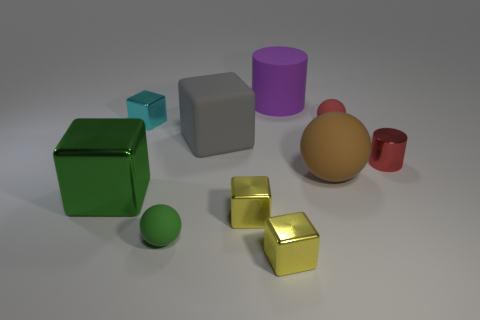Subtract all small red matte spheres. How many spheres are left? 2 Subtract all brown spheres. How many spheres are left? 2 Subtract all cylinders. How many objects are left? 8 Subtract 3 cubes. How many cubes are left? 2 Subtract all green balls. Subtract all yellow cubes. How many balls are left? 2 Subtract all blue cubes. How many brown balls are left? 1 Subtract all tiny green spheres. Subtract all big purple rubber objects. How many objects are left? 8 Add 9 large gray blocks. How many large gray blocks are left? 10 Add 1 red shiny cylinders. How many red shiny cylinders exist? 2 Subtract 0 blue blocks. How many objects are left? 10 